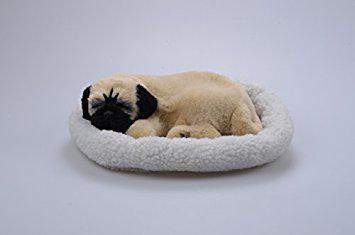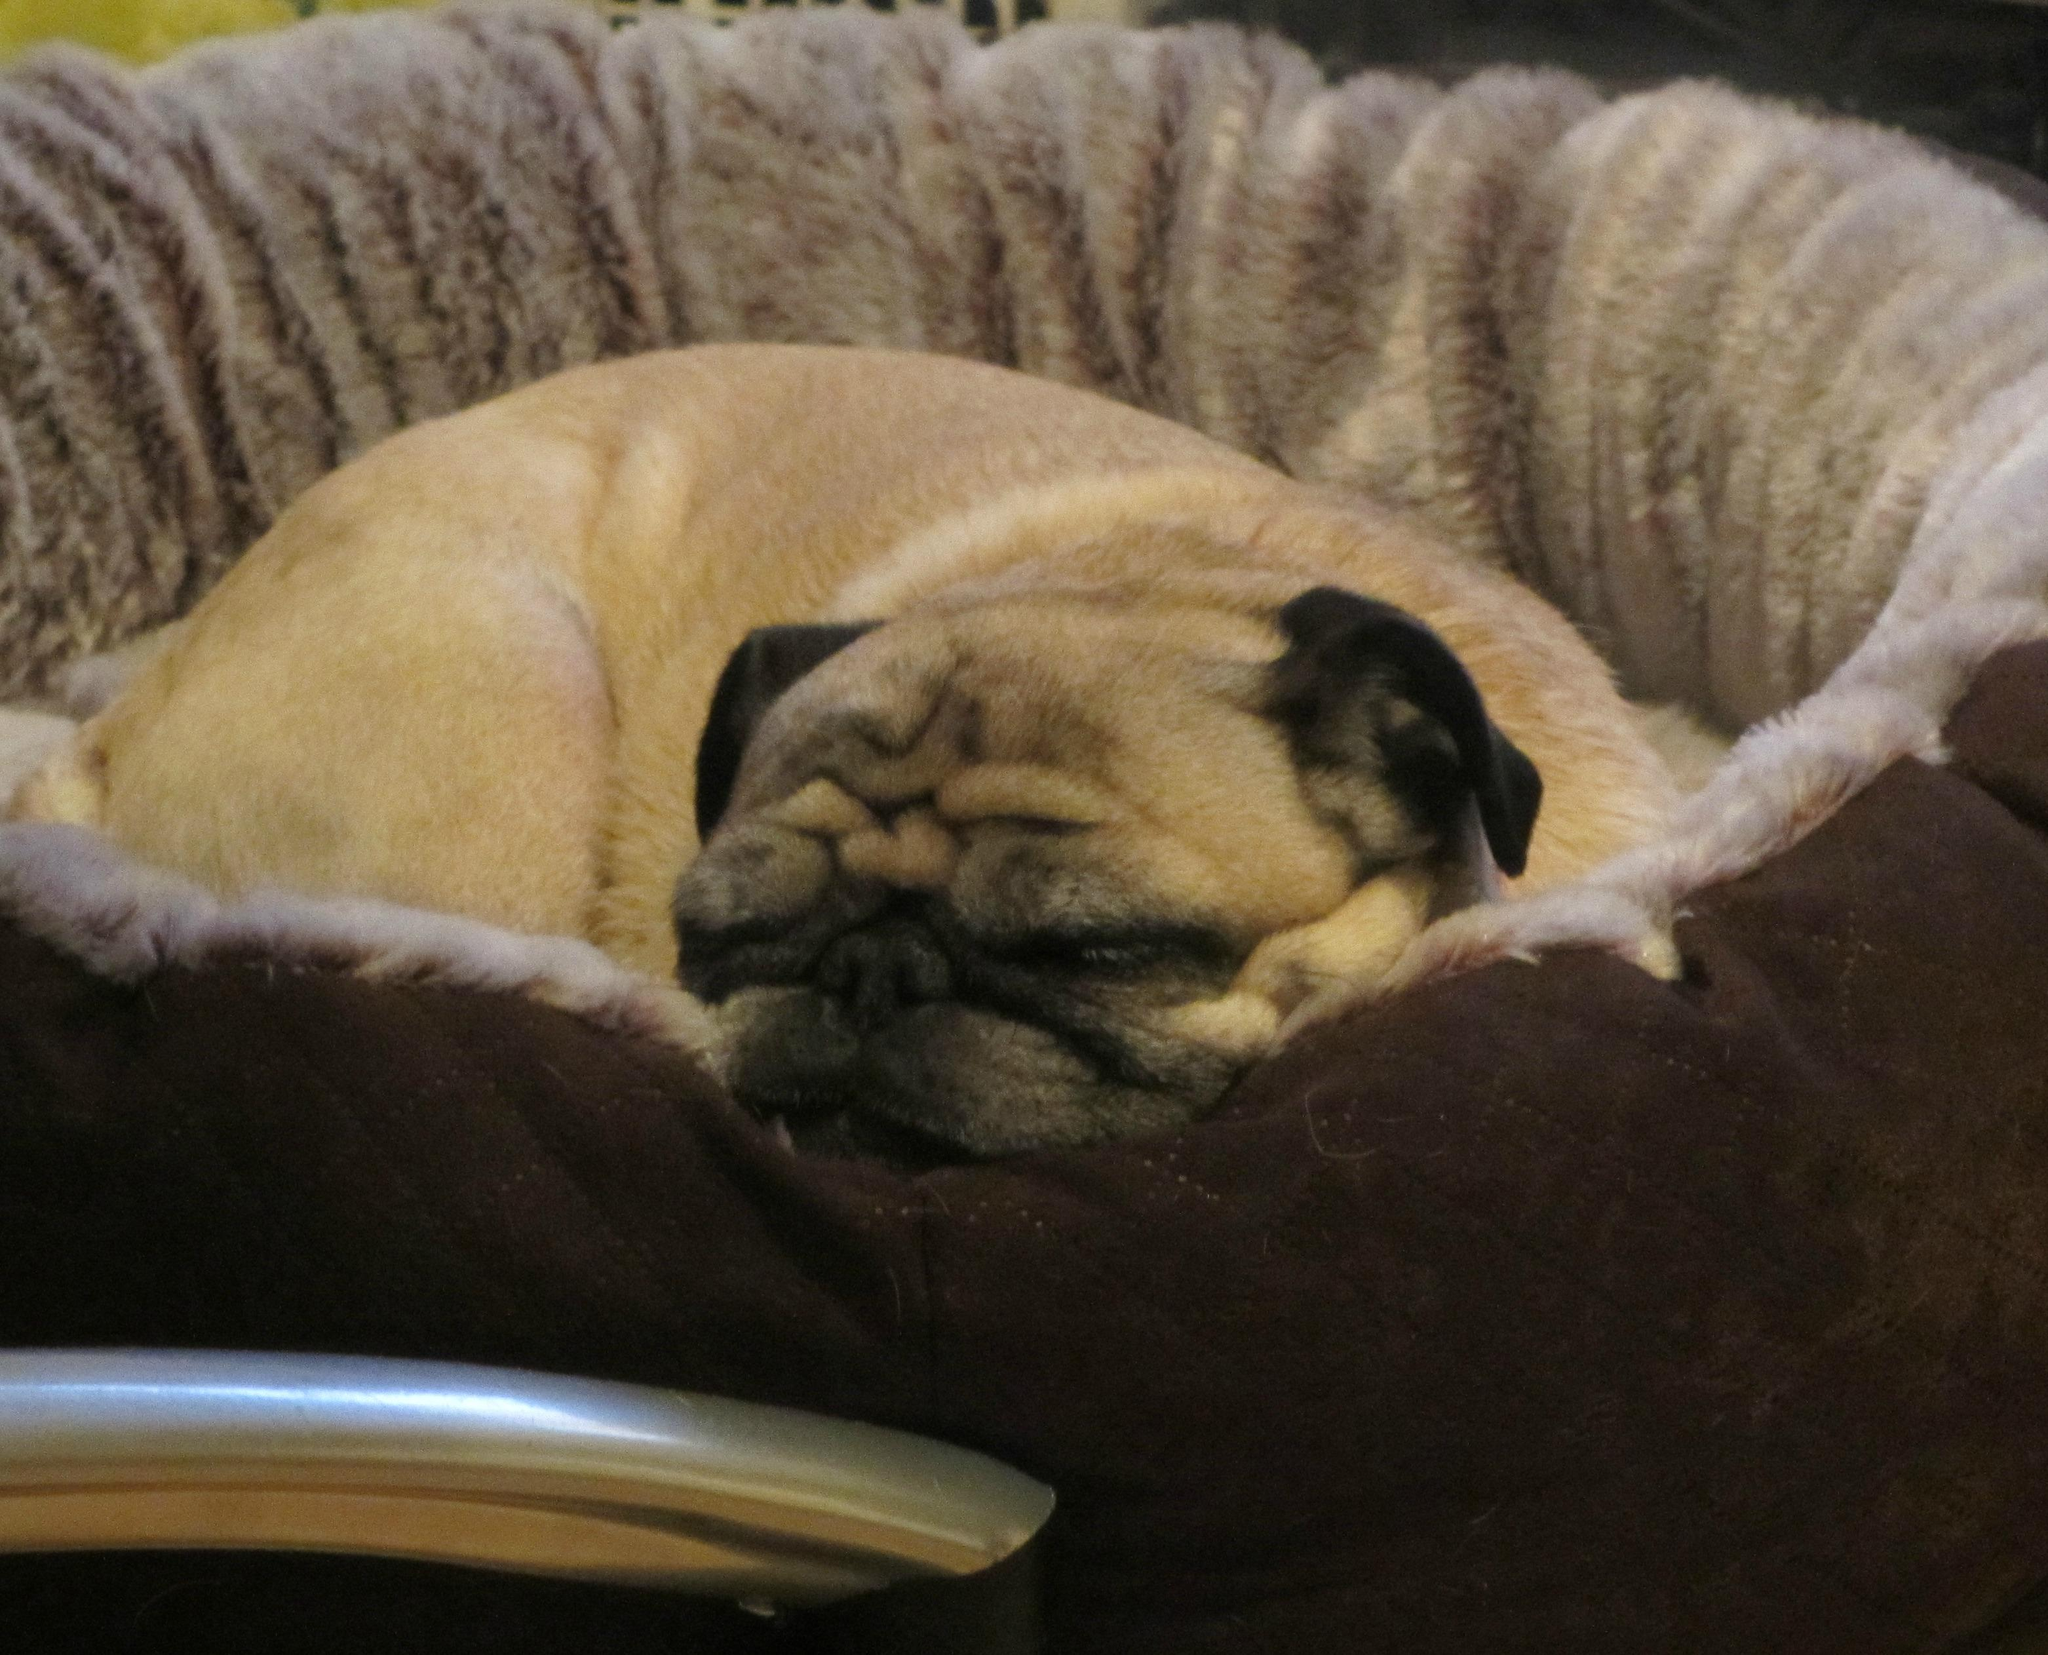The first image is the image on the left, the second image is the image on the right. For the images displayed, is the sentence "The left and right image contains the same number of tan pugs resting on their bed." factually correct? Answer yes or no. Yes. The first image is the image on the left, the second image is the image on the right. Given the left and right images, does the statement "The combined images include two pugs who are sleeping in a plush round pet bed." hold true? Answer yes or no. Yes. 